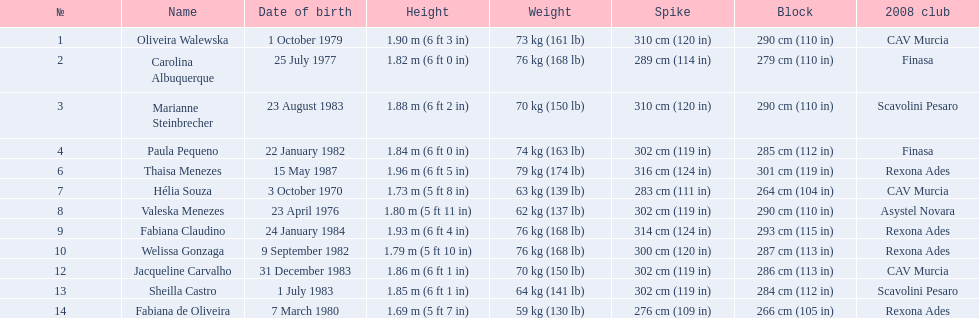What are the complete list of names? Oliveira Walewska, Carolina Albuquerque, Marianne Steinbrecher, Paula Pequeno, Thaisa Menezes, Hélia Souza, Valeska Menezes, Fabiana Claudino, Welissa Gonzaga, Jacqueline Carvalho, Sheilla Castro, Fabiana de Oliveira. What are their individual weights? 73 kg (161 lb), 76 kg (168 lb), 70 kg (150 lb), 74 kg (163 lb), 79 kg (174 lb), 63 kg (139 lb), 62 kg (137 lb), 76 kg (168 lb), 76 kg (168 lb), 70 kg (150 lb), 64 kg (141 lb), 59 kg (130 lb). What was the weight of helia souza, fabiana de oliveira, and sheilla castro? Hélia Souza, Sheilla Castro, Fabiana de Oliveira. And who had a higher weight? Sheilla Castro. 